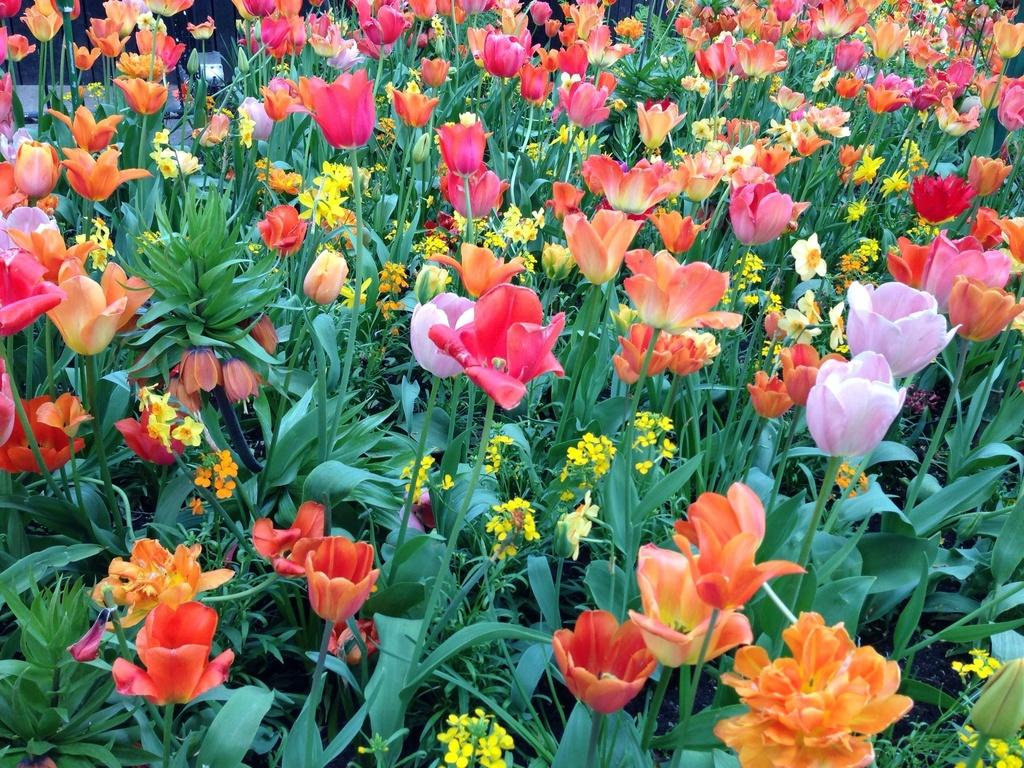What type of plants can be seen in the image? There are flower plants in the image. Can you describe the appearance of the flowers? The flowers have different colors. What type of light treatment is being used on the hill in the image? There is no hill or light treatment present in the image; it features flower plants with different colored flowers. 